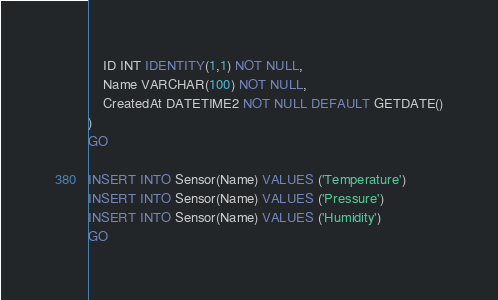Convert code to text. <code><loc_0><loc_0><loc_500><loc_500><_SQL_>	ID INT IDENTITY(1,1) NOT NULL,
	Name VARCHAR(100) NOT NULL,
	CreatedAt DATETIME2 NOT NULL DEFAULT GETDATE()
)
GO

INSERT INTO Sensor(Name) VALUES ('Temperature')
INSERT INTO Sensor(Name) VALUES ('Pressure')
INSERT INTO Sensor(Name) VALUES ('Humidity')
GO</code> 